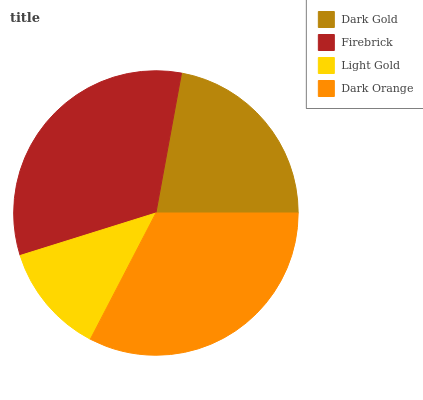Is Light Gold the minimum?
Answer yes or no. Yes. Is Firebrick the maximum?
Answer yes or no. Yes. Is Firebrick the minimum?
Answer yes or no. No. Is Light Gold the maximum?
Answer yes or no. No. Is Firebrick greater than Light Gold?
Answer yes or no. Yes. Is Light Gold less than Firebrick?
Answer yes or no. Yes. Is Light Gold greater than Firebrick?
Answer yes or no. No. Is Firebrick less than Light Gold?
Answer yes or no. No. Is Dark Orange the high median?
Answer yes or no. Yes. Is Dark Gold the low median?
Answer yes or no. Yes. Is Firebrick the high median?
Answer yes or no. No. Is Light Gold the low median?
Answer yes or no. No. 